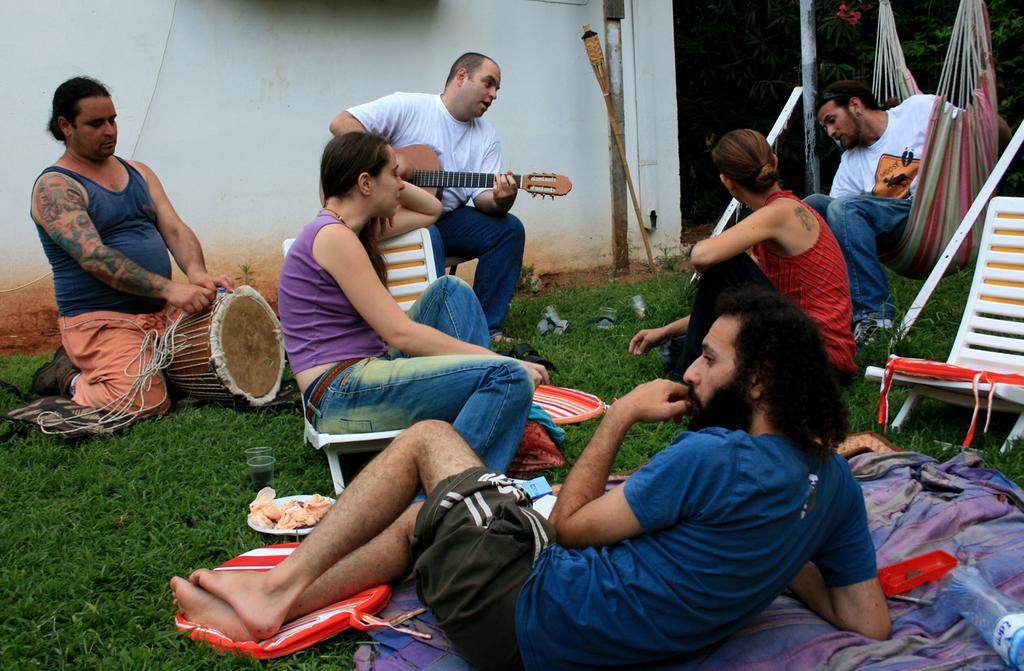How would you summarize this image in a sentence or two? There are 4 men and 2 women in this picture. In the middle this person is playing guitar. On the left a person is repairing a musical instrument. One women in them is sitting on the chair. In the background there is a wall,pole and trees. 